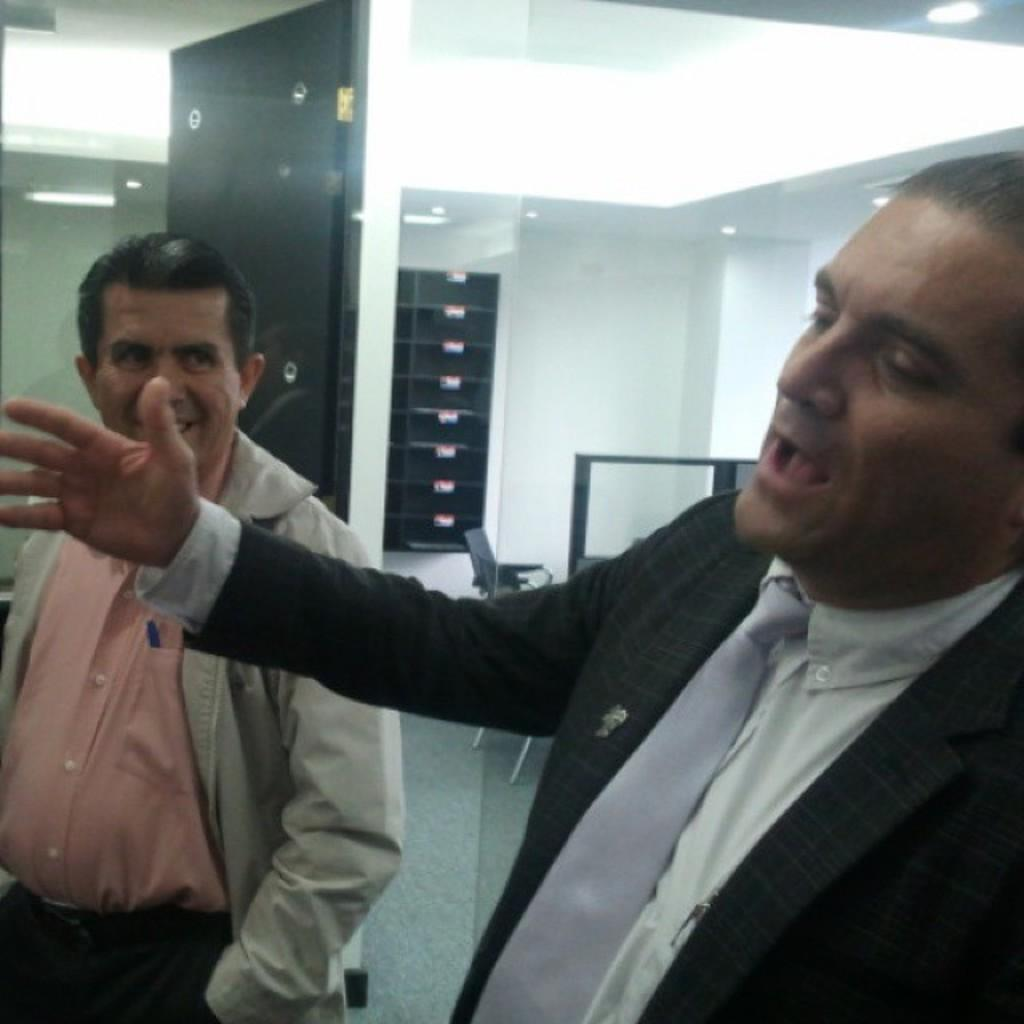How many people are present in the image? There are two men standing in the image. What type of door can be seen in the image? There is a glass door and a wooden door in the image. What is attached to the roof in the image? There are ceiling lights attached to the roof in the image. What type of furniture is present in the image? There is a chair in the image. What decision are the two men making in the image? There is no indication of a decision being made in the image; the men are simply standing. 